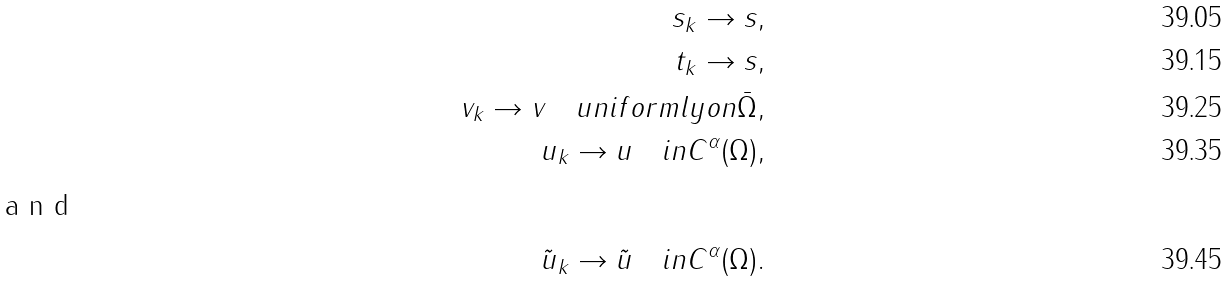Convert formula to latex. <formula><loc_0><loc_0><loc_500><loc_500>s _ { k } \rightarrow s , \\ t _ { k } \rightarrow s , \\ v _ { k } \rightarrow v \quad u n i f o r m l y o n \bar { \Omega } , \\ u _ { k } \rightarrow u \quad i n C ^ { \alpha } ( \Omega ) , \\ \intertext { a n d } \tilde { u } _ { k } \rightarrow \tilde { u } \quad i n C ^ { \alpha } ( \Omega ) .</formula> 